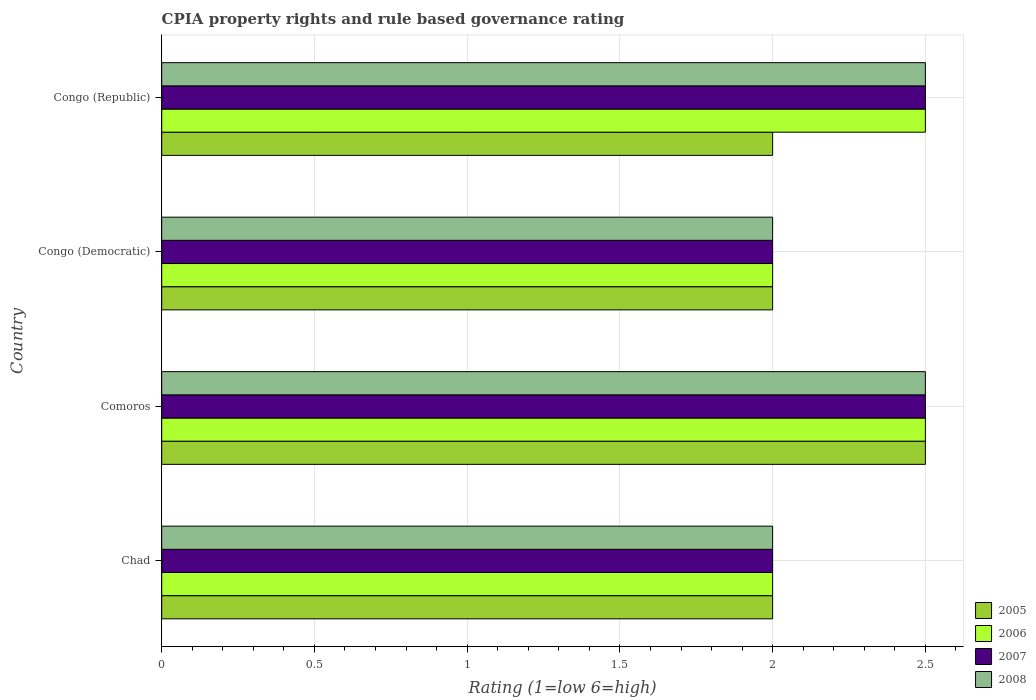Are the number of bars per tick equal to the number of legend labels?
Make the answer very short. Yes. Are the number of bars on each tick of the Y-axis equal?
Ensure brevity in your answer.  Yes. What is the label of the 3rd group of bars from the top?
Your answer should be very brief. Comoros. Across all countries, what is the maximum CPIA rating in 2008?
Offer a terse response. 2.5. In which country was the CPIA rating in 2005 maximum?
Make the answer very short. Comoros. In which country was the CPIA rating in 2007 minimum?
Make the answer very short. Chad. What is the difference between the CPIA rating in 2006 in Chad and the CPIA rating in 2007 in Congo (Republic)?
Keep it short and to the point. -0.5. What is the average CPIA rating in 2008 per country?
Keep it short and to the point. 2.25. What is the ratio of the CPIA rating in 2007 in Comoros to that in Congo (Democratic)?
Ensure brevity in your answer.  1.25. Is the CPIA rating in 2006 in Chad less than that in Congo (Democratic)?
Your response must be concise. No. Is the sum of the CPIA rating in 2008 in Comoros and Congo (Republic) greater than the maximum CPIA rating in 2006 across all countries?
Provide a succinct answer. Yes. What does the 4th bar from the bottom in Comoros represents?
Provide a short and direct response. 2008. Is it the case that in every country, the sum of the CPIA rating in 2006 and CPIA rating in 2007 is greater than the CPIA rating in 2005?
Your answer should be very brief. Yes. How many bars are there?
Make the answer very short. 16. Are the values on the major ticks of X-axis written in scientific E-notation?
Provide a short and direct response. No. Does the graph contain grids?
Your answer should be very brief. Yes. How many legend labels are there?
Offer a very short reply. 4. How are the legend labels stacked?
Your answer should be compact. Vertical. What is the title of the graph?
Give a very brief answer. CPIA property rights and rule based governance rating. What is the label or title of the X-axis?
Provide a short and direct response. Rating (1=low 6=high). What is the label or title of the Y-axis?
Ensure brevity in your answer.  Country. What is the Rating (1=low 6=high) in 2005 in Chad?
Offer a terse response. 2. What is the Rating (1=low 6=high) of 2005 in Comoros?
Your answer should be compact. 2.5. What is the Rating (1=low 6=high) in 2006 in Comoros?
Offer a very short reply. 2.5. What is the Rating (1=low 6=high) in 2006 in Congo (Democratic)?
Offer a very short reply. 2. What is the Rating (1=low 6=high) in 2008 in Congo (Democratic)?
Ensure brevity in your answer.  2. What is the Rating (1=low 6=high) of 2007 in Congo (Republic)?
Provide a succinct answer. 2.5. Across all countries, what is the maximum Rating (1=low 6=high) of 2007?
Your response must be concise. 2.5. Across all countries, what is the maximum Rating (1=low 6=high) in 2008?
Offer a terse response. 2.5. Across all countries, what is the minimum Rating (1=low 6=high) in 2005?
Provide a short and direct response. 2. Across all countries, what is the minimum Rating (1=low 6=high) in 2006?
Provide a short and direct response. 2. Across all countries, what is the minimum Rating (1=low 6=high) in 2007?
Your answer should be very brief. 2. What is the total Rating (1=low 6=high) in 2006 in the graph?
Your answer should be compact. 9. What is the total Rating (1=low 6=high) of 2007 in the graph?
Offer a very short reply. 9. What is the total Rating (1=low 6=high) of 2008 in the graph?
Your answer should be compact. 9. What is the difference between the Rating (1=low 6=high) in 2005 in Chad and that in Comoros?
Give a very brief answer. -0.5. What is the difference between the Rating (1=low 6=high) of 2007 in Chad and that in Comoros?
Your answer should be very brief. -0.5. What is the difference between the Rating (1=low 6=high) of 2008 in Chad and that in Comoros?
Provide a succinct answer. -0.5. What is the difference between the Rating (1=low 6=high) of 2006 in Chad and that in Congo (Democratic)?
Provide a succinct answer. 0. What is the difference between the Rating (1=low 6=high) in 2006 in Chad and that in Congo (Republic)?
Offer a terse response. -0.5. What is the difference between the Rating (1=low 6=high) of 2008 in Chad and that in Congo (Republic)?
Provide a succinct answer. -0.5. What is the difference between the Rating (1=low 6=high) of 2005 in Comoros and that in Congo (Democratic)?
Offer a terse response. 0.5. What is the difference between the Rating (1=low 6=high) in 2006 in Comoros and that in Congo (Republic)?
Keep it short and to the point. 0. What is the difference between the Rating (1=low 6=high) of 2007 in Comoros and that in Congo (Republic)?
Make the answer very short. 0. What is the difference between the Rating (1=low 6=high) in 2005 in Congo (Democratic) and that in Congo (Republic)?
Ensure brevity in your answer.  0. What is the difference between the Rating (1=low 6=high) in 2006 in Congo (Democratic) and that in Congo (Republic)?
Provide a succinct answer. -0.5. What is the difference between the Rating (1=low 6=high) in 2007 in Congo (Democratic) and that in Congo (Republic)?
Give a very brief answer. -0.5. What is the difference between the Rating (1=low 6=high) in 2005 in Chad and the Rating (1=low 6=high) in 2006 in Comoros?
Give a very brief answer. -0.5. What is the difference between the Rating (1=low 6=high) of 2005 in Chad and the Rating (1=low 6=high) of 2008 in Comoros?
Your response must be concise. -0.5. What is the difference between the Rating (1=low 6=high) in 2006 in Chad and the Rating (1=low 6=high) in 2008 in Comoros?
Offer a very short reply. -0.5. What is the difference between the Rating (1=low 6=high) of 2007 in Chad and the Rating (1=low 6=high) of 2008 in Comoros?
Keep it short and to the point. -0.5. What is the difference between the Rating (1=low 6=high) in 2005 in Chad and the Rating (1=low 6=high) in 2006 in Congo (Democratic)?
Your response must be concise. 0. What is the difference between the Rating (1=low 6=high) in 2006 in Chad and the Rating (1=low 6=high) in 2007 in Congo (Democratic)?
Your answer should be very brief. 0. What is the difference between the Rating (1=low 6=high) of 2007 in Chad and the Rating (1=low 6=high) of 2008 in Congo (Democratic)?
Your response must be concise. 0. What is the difference between the Rating (1=low 6=high) in 2005 in Chad and the Rating (1=low 6=high) in 2006 in Congo (Republic)?
Give a very brief answer. -0.5. What is the difference between the Rating (1=low 6=high) of 2005 in Chad and the Rating (1=low 6=high) of 2007 in Congo (Republic)?
Offer a very short reply. -0.5. What is the difference between the Rating (1=low 6=high) in 2005 in Chad and the Rating (1=low 6=high) in 2008 in Congo (Republic)?
Provide a succinct answer. -0.5. What is the difference between the Rating (1=low 6=high) in 2005 in Comoros and the Rating (1=low 6=high) in 2006 in Congo (Democratic)?
Keep it short and to the point. 0.5. What is the difference between the Rating (1=low 6=high) in 2005 in Comoros and the Rating (1=low 6=high) in 2007 in Congo (Democratic)?
Offer a very short reply. 0.5. What is the difference between the Rating (1=low 6=high) in 2005 in Comoros and the Rating (1=low 6=high) in 2008 in Congo (Democratic)?
Offer a terse response. 0.5. What is the difference between the Rating (1=low 6=high) in 2006 in Comoros and the Rating (1=low 6=high) in 2007 in Congo (Democratic)?
Ensure brevity in your answer.  0.5. What is the difference between the Rating (1=low 6=high) in 2007 in Comoros and the Rating (1=low 6=high) in 2008 in Congo (Democratic)?
Ensure brevity in your answer.  0.5. What is the difference between the Rating (1=low 6=high) of 2005 in Comoros and the Rating (1=low 6=high) of 2007 in Congo (Republic)?
Offer a terse response. 0. What is the difference between the Rating (1=low 6=high) of 2005 in Comoros and the Rating (1=low 6=high) of 2008 in Congo (Republic)?
Make the answer very short. 0. What is the difference between the Rating (1=low 6=high) in 2006 in Comoros and the Rating (1=low 6=high) in 2007 in Congo (Republic)?
Keep it short and to the point. 0. What is the difference between the Rating (1=low 6=high) of 2005 in Congo (Democratic) and the Rating (1=low 6=high) of 2006 in Congo (Republic)?
Ensure brevity in your answer.  -0.5. What is the difference between the Rating (1=low 6=high) of 2005 in Congo (Democratic) and the Rating (1=low 6=high) of 2007 in Congo (Republic)?
Your answer should be very brief. -0.5. What is the difference between the Rating (1=low 6=high) of 2005 in Congo (Democratic) and the Rating (1=low 6=high) of 2008 in Congo (Republic)?
Keep it short and to the point. -0.5. What is the difference between the Rating (1=low 6=high) in 2006 in Congo (Democratic) and the Rating (1=low 6=high) in 2007 in Congo (Republic)?
Provide a succinct answer. -0.5. What is the average Rating (1=low 6=high) in 2005 per country?
Your answer should be compact. 2.12. What is the average Rating (1=low 6=high) in 2006 per country?
Provide a short and direct response. 2.25. What is the average Rating (1=low 6=high) in 2007 per country?
Offer a very short reply. 2.25. What is the average Rating (1=low 6=high) in 2008 per country?
Keep it short and to the point. 2.25. What is the difference between the Rating (1=low 6=high) in 2005 and Rating (1=low 6=high) in 2006 in Chad?
Make the answer very short. 0. What is the difference between the Rating (1=low 6=high) in 2006 and Rating (1=low 6=high) in 2008 in Chad?
Offer a very short reply. 0. What is the difference between the Rating (1=low 6=high) in 2006 and Rating (1=low 6=high) in 2007 in Comoros?
Your answer should be compact. 0. What is the difference between the Rating (1=low 6=high) in 2007 and Rating (1=low 6=high) in 2008 in Comoros?
Offer a very short reply. 0. What is the difference between the Rating (1=low 6=high) of 2005 and Rating (1=low 6=high) of 2006 in Congo (Democratic)?
Offer a terse response. 0. What is the difference between the Rating (1=low 6=high) of 2006 and Rating (1=low 6=high) of 2007 in Congo (Democratic)?
Your answer should be compact. 0. What is the difference between the Rating (1=low 6=high) of 2007 and Rating (1=low 6=high) of 2008 in Congo (Democratic)?
Provide a short and direct response. 0. What is the difference between the Rating (1=low 6=high) of 2005 and Rating (1=low 6=high) of 2007 in Congo (Republic)?
Keep it short and to the point. -0.5. What is the difference between the Rating (1=low 6=high) in 2006 and Rating (1=low 6=high) in 2007 in Congo (Republic)?
Give a very brief answer. 0. What is the difference between the Rating (1=low 6=high) of 2006 and Rating (1=low 6=high) of 2008 in Congo (Republic)?
Offer a very short reply. 0. What is the difference between the Rating (1=low 6=high) in 2007 and Rating (1=low 6=high) in 2008 in Congo (Republic)?
Ensure brevity in your answer.  0. What is the ratio of the Rating (1=low 6=high) of 2008 in Chad to that in Comoros?
Provide a short and direct response. 0.8. What is the ratio of the Rating (1=low 6=high) in 2006 in Chad to that in Congo (Democratic)?
Keep it short and to the point. 1. What is the ratio of the Rating (1=low 6=high) in 2007 in Chad to that in Congo (Republic)?
Give a very brief answer. 0.8. What is the ratio of the Rating (1=low 6=high) of 2008 in Chad to that in Congo (Republic)?
Give a very brief answer. 0.8. What is the ratio of the Rating (1=low 6=high) of 2005 in Comoros to that in Congo (Democratic)?
Give a very brief answer. 1.25. What is the ratio of the Rating (1=low 6=high) in 2006 in Comoros to that in Congo (Democratic)?
Give a very brief answer. 1.25. What is the ratio of the Rating (1=low 6=high) of 2008 in Comoros to that in Congo (Democratic)?
Your response must be concise. 1.25. What is the ratio of the Rating (1=low 6=high) in 2005 in Comoros to that in Congo (Republic)?
Give a very brief answer. 1.25. What is the ratio of the Rating (1=low 6=high) of 2006 in Comoros to that in Congo (Republic)?
Make the answer very short. 1. What is the ratio of the Rating (1=low 6=high) of 2007 in Comoros to that in Congo (Republic)?
Provide a short and direct response. 1. What is the ratio of the Rating (1=low 6=high) of 2006 in Congo (Democratic) to that in Congo (Republic)?
Provide a short and direct response. 0.8. What is the ratio of the Rating (1=low 6=high) in 2007 in Congo (Democratic) to that in Congo (Republic)?
Your response must be concise. 0.8. What is the difference between the highest and the second highest Rating (1=low 6=high) in 2006?
Offer a terse response. 0. What is the difference between the highest and the second highest Rating (1=low 6=high) of 2008?
Provide a short and direct response. 0. What is the difference between the highest and the lowest Rating (1=low 6=high) in 2005?
Ensure brevity in your answer.  0.5. What is the difference between the highest and the lowest Rating (1=low 6=high) in 2007?
Your answer should be compact. 0.5. 